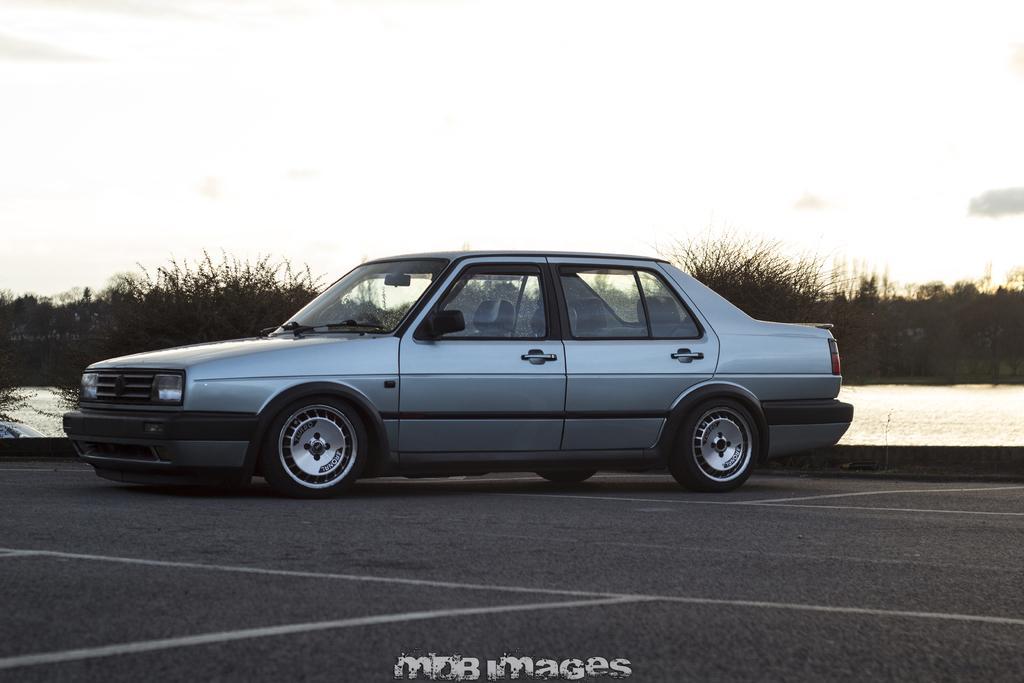Describe this image in one or two sentences. In this picture I can observe a car on the road in the middle of the picture. In the background I can observe plants and sky. 